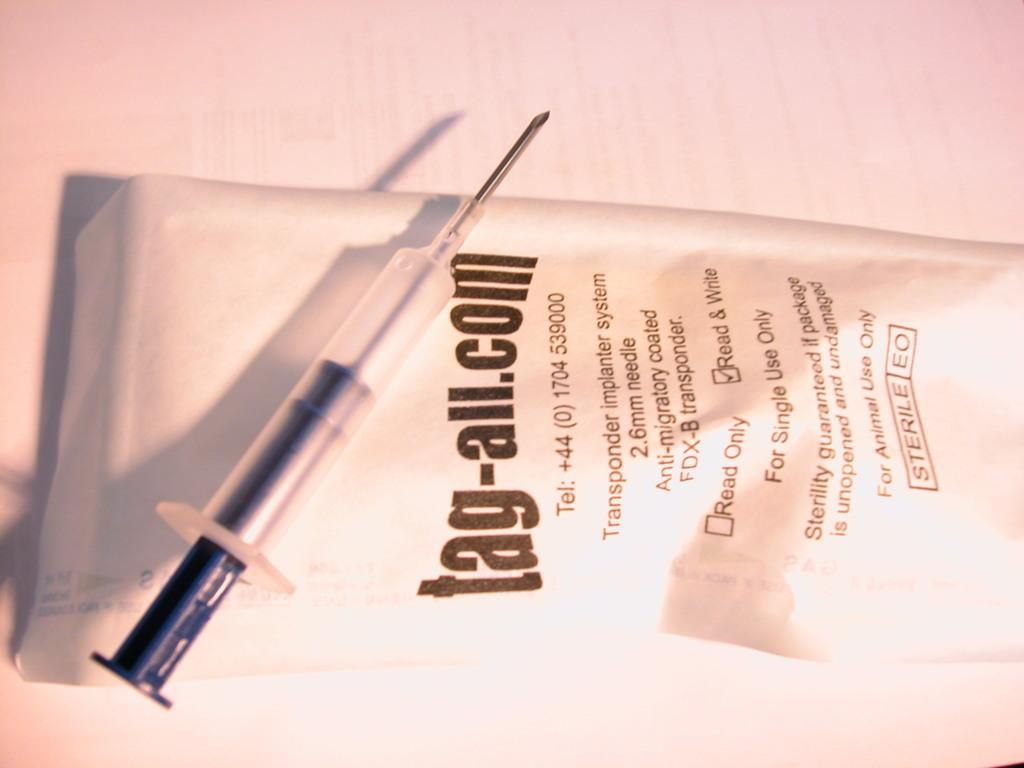What is the main object in the image? There is an injection in the image. What else can be seen in the image besides the injection? There is a paper in the image. What type of curve is present in the image? There is no curve mentioned or visible in the image. 